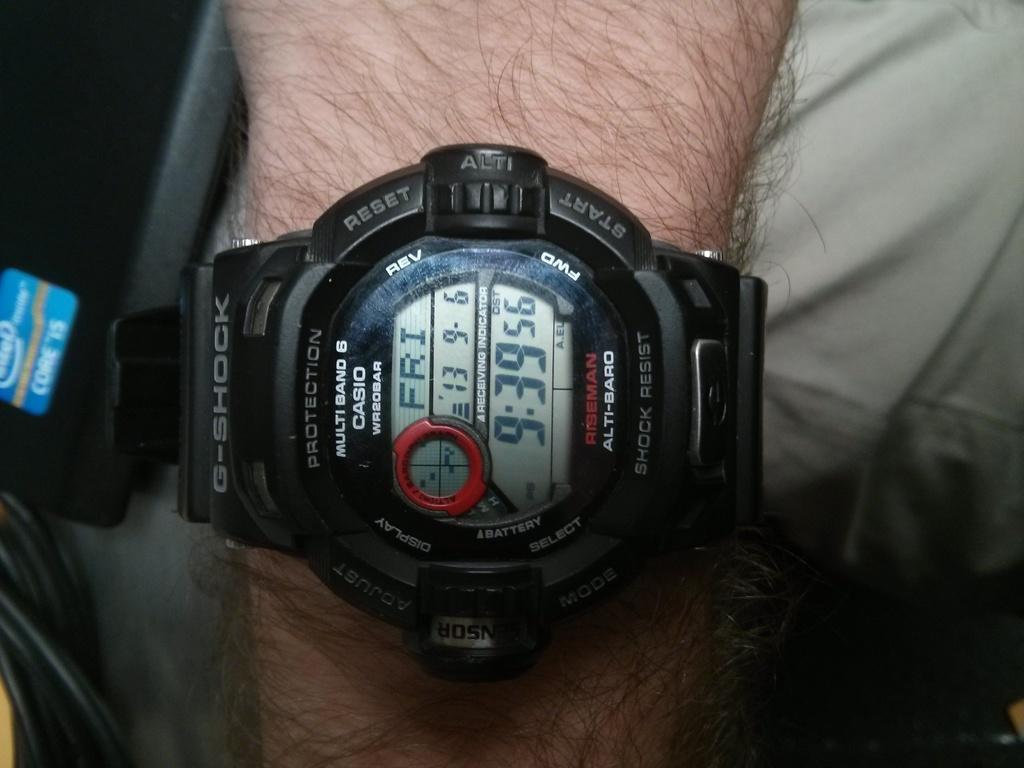What day is it?
Offer a very short reply. Friday. 